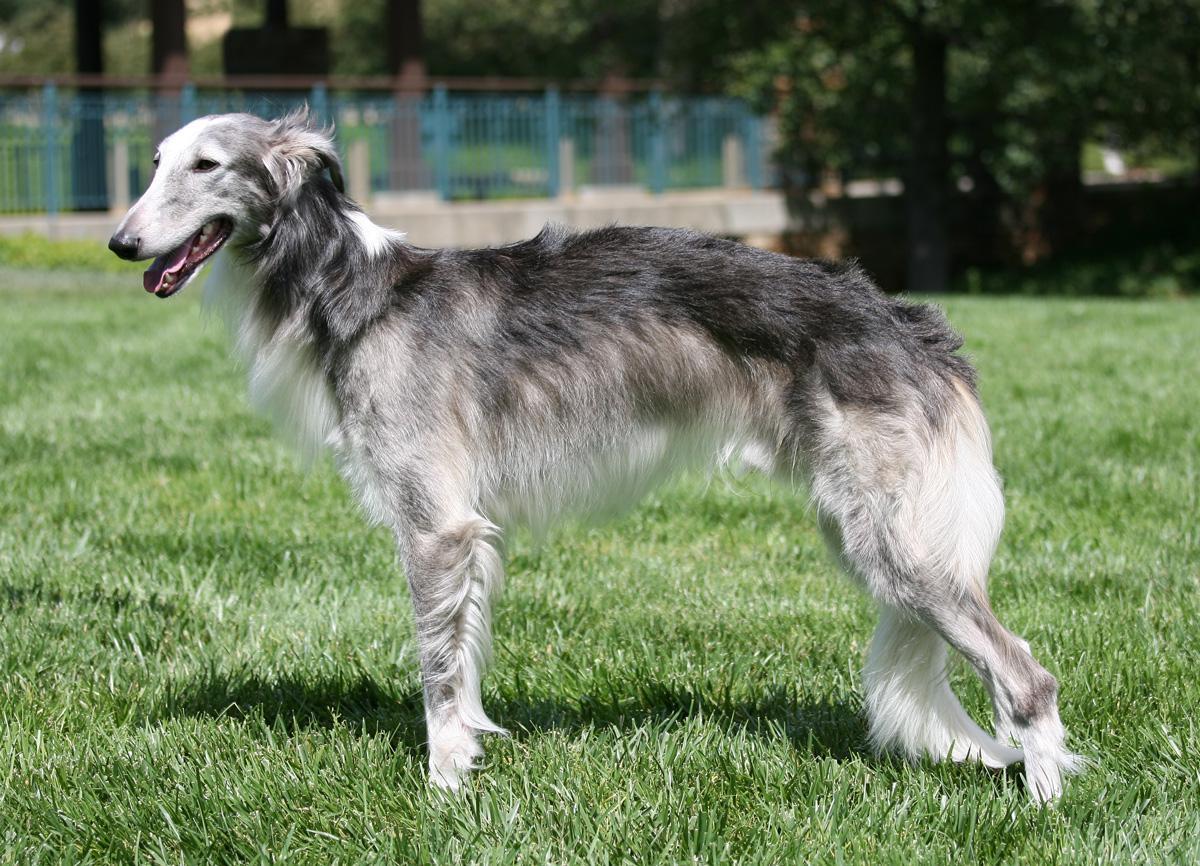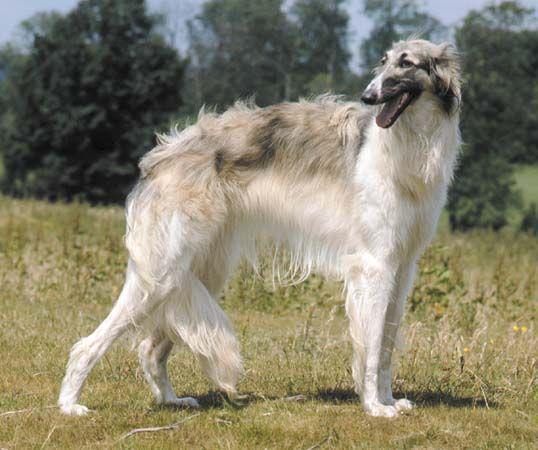The first image is the image on the left, the second image is the image on the right. Examine the images to the left and right. Is the description "In at least one image there is a white and light brown dog facing left." accurate? Answer yes or no. No. The first image is the image on the left, the second image is the image on the right. Assess this claim about the two images: "The combined images include one nearly white dog and one orange-and-white dog, and all dogs are standing in profile looking in the same direction their body is turned.". Correct or not? Answer yes or no. No. 